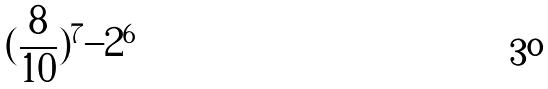<formula> <loc_0><loc_0><loc_500><loc_500>( \frac { 8 } { 1 0 } ) ^ { 7 } - 2 ^ { 6 }</formula> 